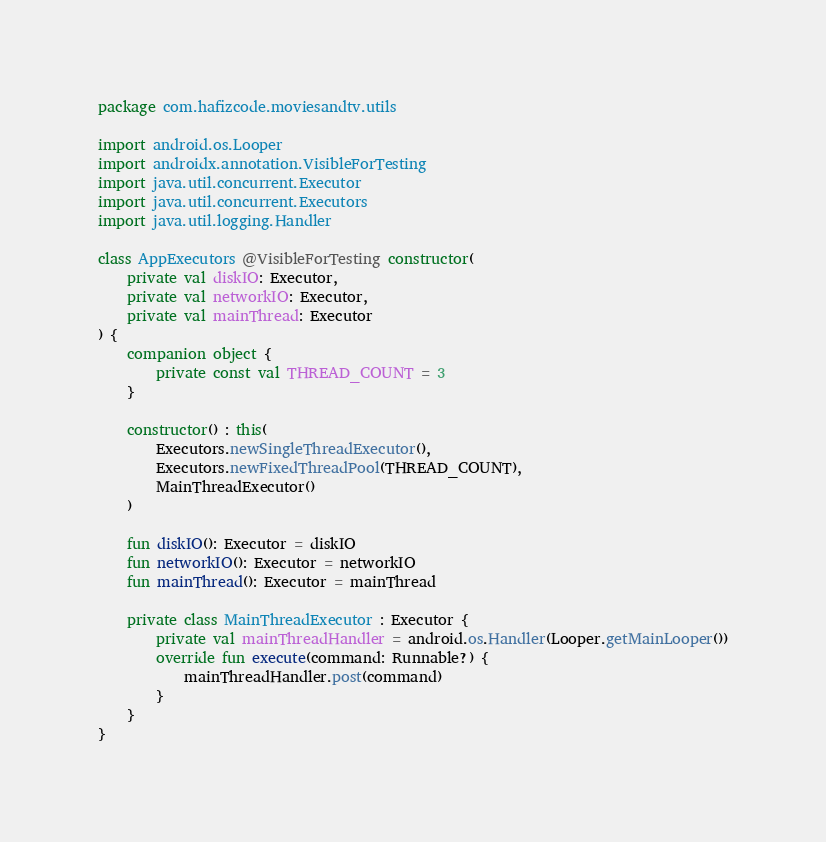<code> <loc_0><loc_0><loc_500><loc_500><_Kotlin_>package com.hafizcode.moviesandtv.utils

import android.os.Looper
import androidx.annotation.VisibleForTesting
import java.util.concurrent.Executor
import java.util.concurrent.Executors
import java.util.logging.Handler

class AppExecutors @VisibleForTesting constructor(
    private val diskIO: Executor,
    private val networkIO: Executor,
    private val mainThread: Executor
) {
    companion object {
        private const val THREAD_COUNT = 3
    }

    constructor() : this(
        Executors.newSingleThreadExecutor(),
        Executors.newFixedThreadPool(THREAD_COUNT),
        MainThreadExecutor()
    )

    fun diskIO(): Executor = diskIO
    fun networkIO(): Executor = networkIO
    fun mainThread(): Executor = mainThread

    private class MainThreadExecutor : Executor {
        private val mainThreadHandler = android.os.Handler(Looper.getMainLooper())
        override fun execute(command: Runnable?) {
            mainThreadHandler.post(command)
        }
    }
}</code> 